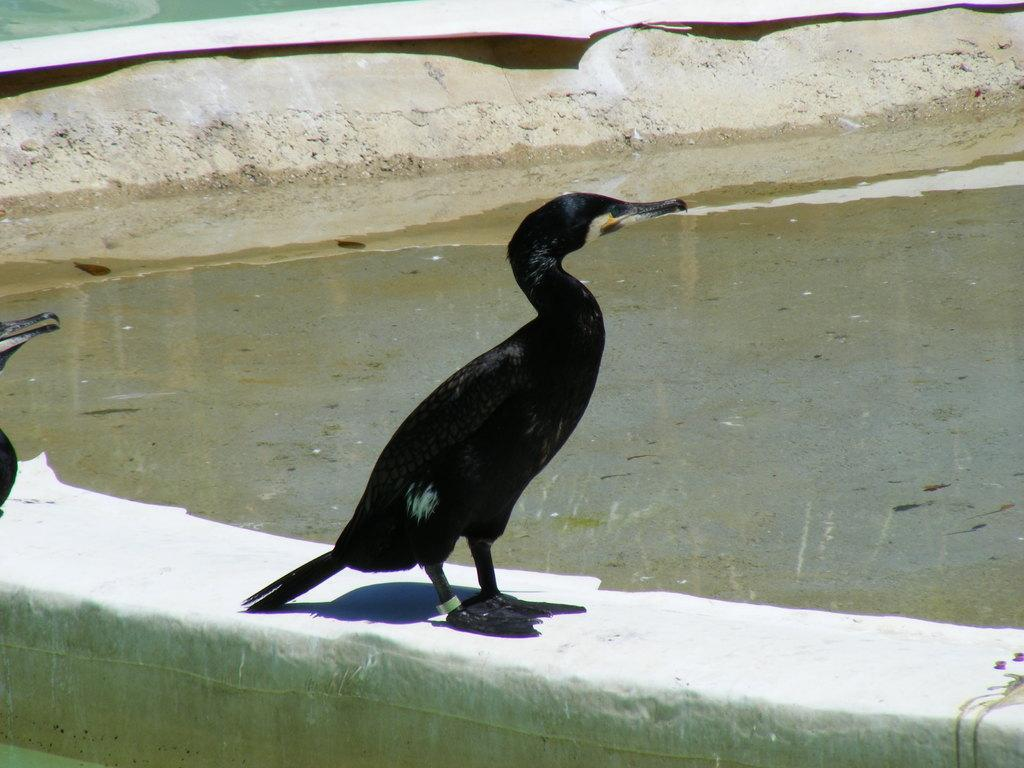What type of animals can be seen in the image? There are birds in the image. Where are the birds located? The birds are on a wall. What else can be seen in the image besides the birds? There is water visible in the image. Can you describe the background of the image? There is an object in the background of the image. How many eggs are the birds sitting on in the image? There are no eggs visible in the image; only the birds on the wall and the water in the background can be seen. 